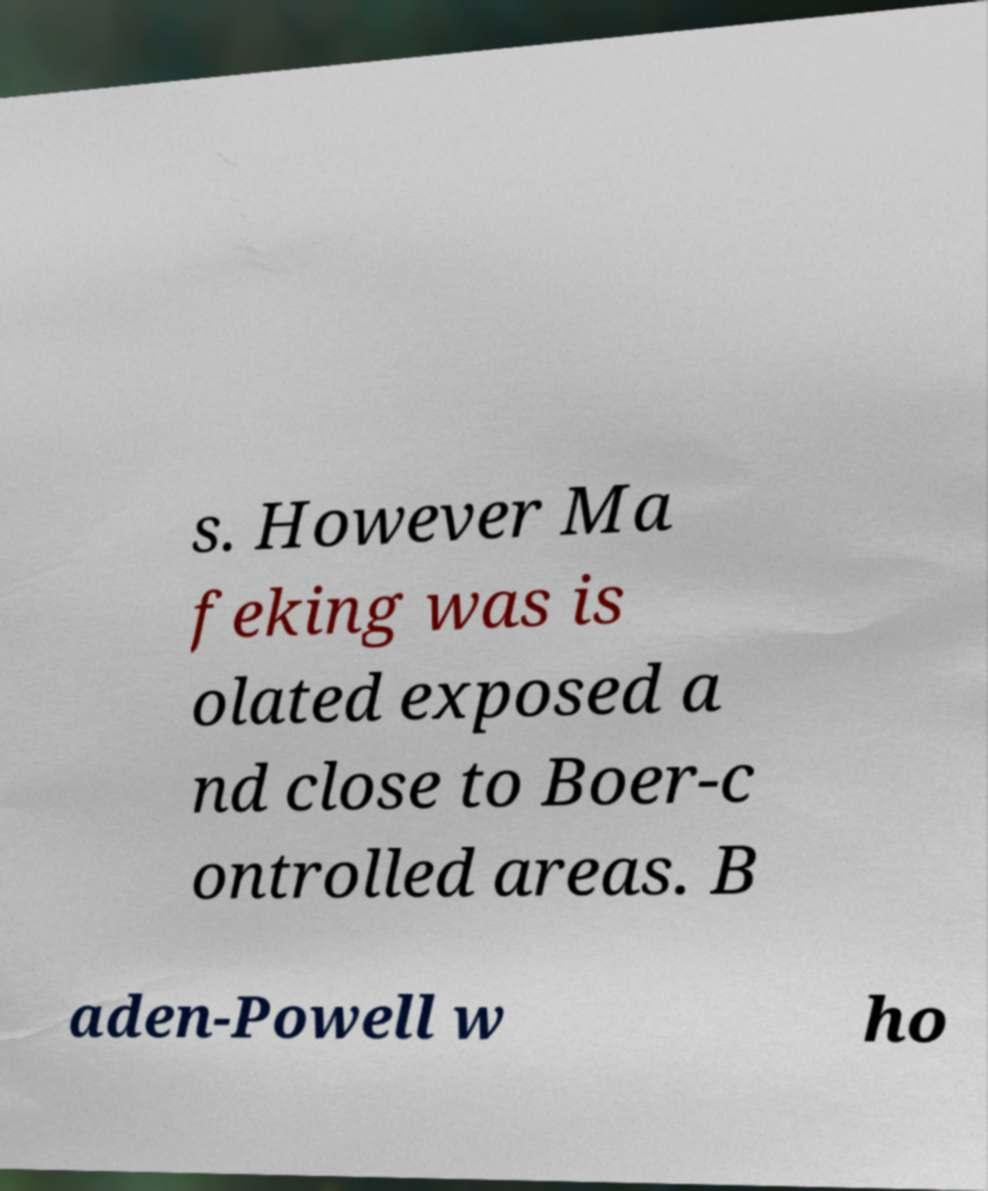For documentation purposes, I need the text within this image transcribed. Could you provide that? s. However Ma feking was is olated exposed a nd close to Boer-c ontrolled areas. B aden-Powell w ho 